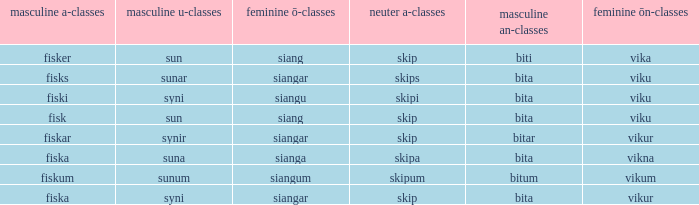What is the masculine an form for the word with a feminine ö ending of siangar and a masculine u ending of sunar? Bita. 